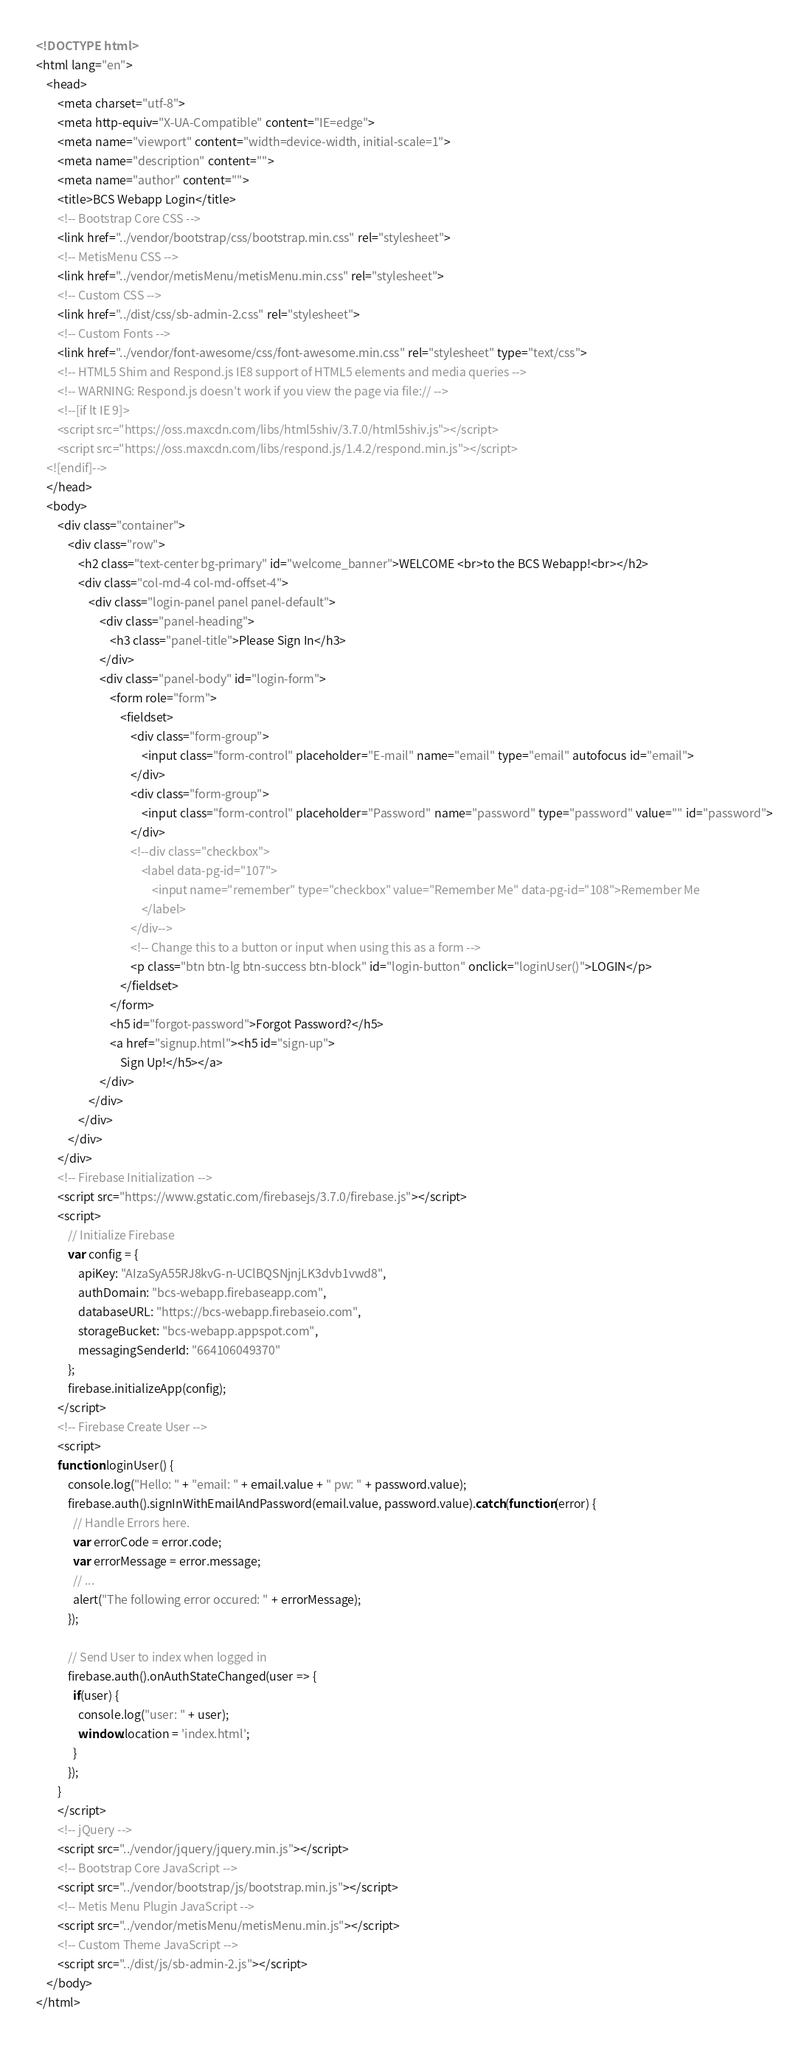<code> <loc_0><loc_0><loc_500><loc_500><_HTML_><!DOCTYPE html> 
<html lang="en"> 
    <head> 
        <meta charset="utf-8"> 
        <meta http-equiv="X-UA-Compatible" content="IE=edge"> 
        <meta name="viewport" content="width=device-width, initial-scale=1"> 
        <meta name="description" content=""> 
        <meta name="author" content=""> 
        <title>BCS Webapp Login</title>         
        <!-- Bootstrap Core CSS -->         
        <link href="../vendor/bootstrap/css/bootstrap.min.css" rel="stylesheet"> 
        <!-- MetisMenu CSS -->         
        <link href="../vendor/metisMenu/metisMenu.min.css" rel="stylesheet"> 
        <!-- Custom CSS -->         
        <link href="../dist/css/sb-admin-2.css" rel="stylesheet"> 
        <!-- Custom Fonts -->         
        <link href="../vendor/font-awesome/css/font-awesome.min.css" rel="stylesheet" type="text/css"> 
        <!-- HTML5 Shim and Respond.js IE8 support of HTML5 elements and media queries -->         
        <!-- WARNING: Respond.js doesn't work if you view the page via file:// -->         
        <!--[if lt IE 9]>
        <script src="https://oss.maxcdn.com/libs/html5shiv/3.7.0/html5shiv.js"></script>
        <script src="https://oss.maxcdn.com/libs/respond.js/1.4.2/respond.min.js"></script>
    <![endif]-->         
    </head>     
    <body> 
        <div class="container"> 
            <div class="row"> 
                <h2 class="text-center bg-primary" id="welcome_banner">WELCOME <br>to the BCS Webapp!<br></h2> 
                <div class="col-md-4 col-md-offset-4"> 
                    <div class="login-panel panel panel-default"> 
                        <div class="panel-heading"> 
                            <h3 class="panel-title">Please Sign In</h3> 
                        </div>                         
                        <div class="panel-body" id="login-form"> 
                            <form role="form"> 
                                <fieldset> 
                                    <div class="form-group"> 
                                        <input class="form-control" placeholder="E-mail" name="email" type="email" autofocus id="email"> 
                                    </div>                                     
                                    <div class="form-group"> 
                                        <input class="form-control" placeholder="Password" name="password" type="password" value="" id="password"> 
                                    </div>
                                    <!--div class="checkbox">
                                        <label data-pg-id="107"> 
                                            <input name="remember" type="checkbox" value="Remember Me" data-pg-id="108">Remember Me
                                        </label>
                                    </div-->
                                    <!-- Change this to a button or input when using this as a form -->
                                    <p class="btn btn-lg btn-success btn-block" id="login-button" onclick="loginUser()">LOGIN</p> 
                                </fieldset>
                            </form>
                            <h5 id="forgot-password">Forgot Password?</h5> 
                            <a href="signup.html"><h5 id="sign-up"> 
                                Sign Up!</h5></a> 
                        </div>
                    </div>
                </div>
            </div>
        </div>
        <!-- Firebase Initialization -->
        <script src="https://www.gstatic.com/firebasejs/3.7.0/firebase.js"></script>
        <script>
            // Initialize Firebase
            var config = {
                apiKey: "AIzaSyA55RJ8kvG-n-UClBQSNjnjLK3dvb1vwd8",
                authDomain: "bcs-webapp.firebaseapp.com",
                databaseURL: "https://bcs-webapp.firebaseio.com",
                storageBucket: "bcs-webapp.appspot.com",
                messagingSenderId: "664106049370"
            };
            firebase.initializeApp(config);
        </script>
        <!-- Firebase Create User -->         
        <script>
        function loginUser() {
            console.log("Hello: " + "email: " + email.value + " pw: " + password.value);
            firebase.auth().signInWithEmailAndPassword(email.value, password.value).catch(function(error) {
              // Handle Errors here.
              var errorCode = error.code;
              var errorMessage = error.message;
              // ...
              alert("The following error occured: " + errorMessage);
            });
            
            // Send User to index when logged in
            firebase.auth().onAuthStateChanged(user => {
              if(user) {
                console.log("user: " + user);
                window.location = 'index.html';
              }
            });
        }
        </script>
        <!-- jQuery -->
        <script src="../vendor/jquery/jquery.min.js"></script>
        <!-- Bootstrap Core JavaScript -->
        <script src="../vendor/bootstrap/js/bootstrap.min.js"></script>
        <!-- Metis Menu Plugin JavaScript -->
        <script src="../vendor/metisMenu/metisMenu.min.js"></script>
        <!-- Custom Theme JavaScript -->
        <script src="../dist/js/sb-admin-2.js"></script>
    </body>
</html>
</code> 